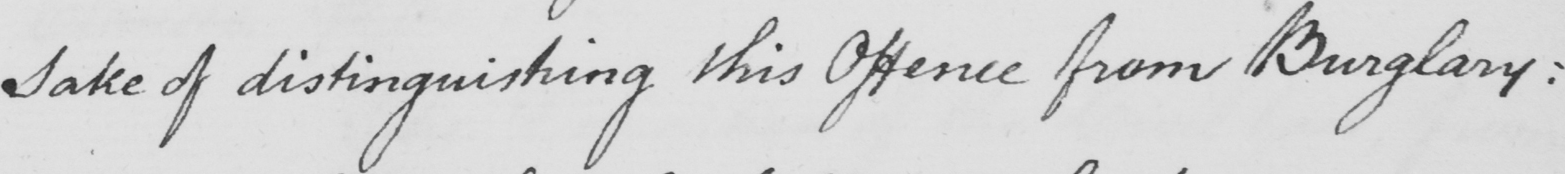Can you read and transcribe this handwriting? sake of distinguishing this Offence from Burglary : 